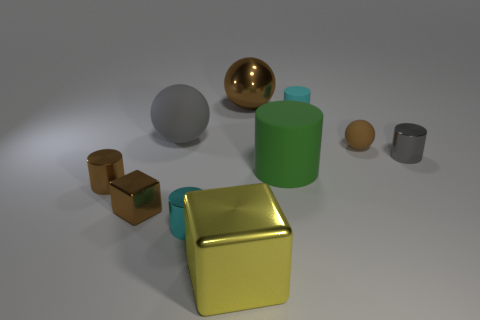There is a metallic thing that is behind the gray object in front of the large object left of the yellow metal thing; what shape is it?
Provide a succinct answer. Sphere. There is a tiny gray shiny object; what shape is it?
Your answer should be compact. Cylinder. What is the shape of the brown rubber object that is the same size as the gray metal object?
Keep it short and to the point. Sphere. What number of other things are the same color as the big matte sphere?
Keep it short and to the point. 1. There is a small brown thing right of the tiny cyan rubber object; is its shape the same as the metal object behind the cyan matte cylinder?
Your answer should be compact. Yes. What number of things are shiny blocks right of the brown cube or brown metal things that are left of the tiny cyan metallic thing?
Provide a succinct answer. 3. What number of other things are there of the same material as the small brown sphere
Your answer should be very brief. 3. Is the tiny cyan cylinder left of the yellow cube made of the same material as the large green thing?
Provide a short and direct response. No. Are there more matte objects that are behind the gray rubber sphere than green objects that are on the right side of the large green thing?
Keep it short and to the point. Yes. What number of objects are either blocks right of the brown shiny block or brown objects?
Offer a terse response. 5. 